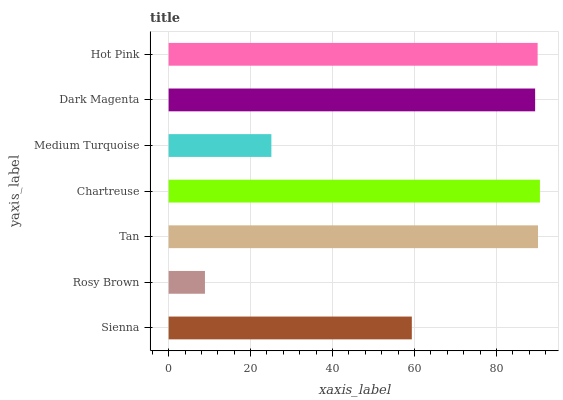Is Rosy Brown the minimum?
Answer yes or no. Yes. Is Chartreuse the maximum?
Answer yes or no. Yes. Is Tan the minimum?
Answer yes or no. No. Is Tan the maximum?
Answer yes or no. No. Is Tan greater than Rosy Brown?
Answer yes or no. Yes. Is Rosy Brown less than Tan?
Answer yes or no. Yes. Is Rosy Brown greater than Tan?
Answer yes or no. No. Is Tan less than Rosy Brown?
Answer yes or no. No. Is Dark Magenta the high median?
Answer yes or no. Yes. Is Dark Magenta the low median?
Answer yes or no. Yes. Is Chartreuse the high median?
Answer yes or no. No. Is Hot Pink the low median?
Answer yes or no. No. 